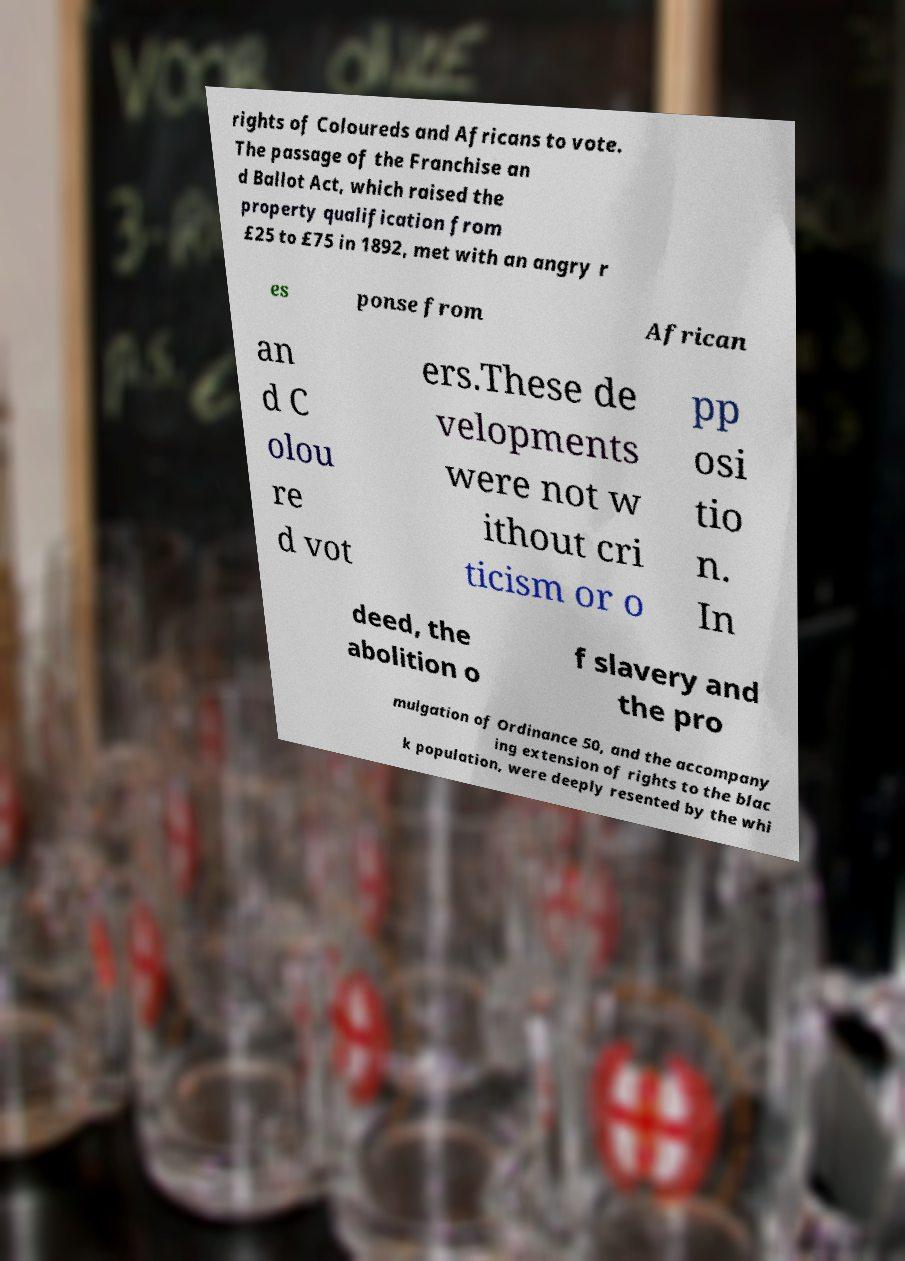Could you extract and type out the text from this image? rights of Coloureds and Africans to vote. The passage of the Franchise an d Ballot Act, which raised the property qualification from £25 to £75 in 1892, met with an angry r es ponse from African an d C olou re d vot ers.These de velopments were not w ithout cri ticism or o pp osi tio n. In deed, the abolition o f slavery and the pro mulgation of Ordinance 50, and the accompany ing extension of rights to the blac k population, were deeply resented by the whi 